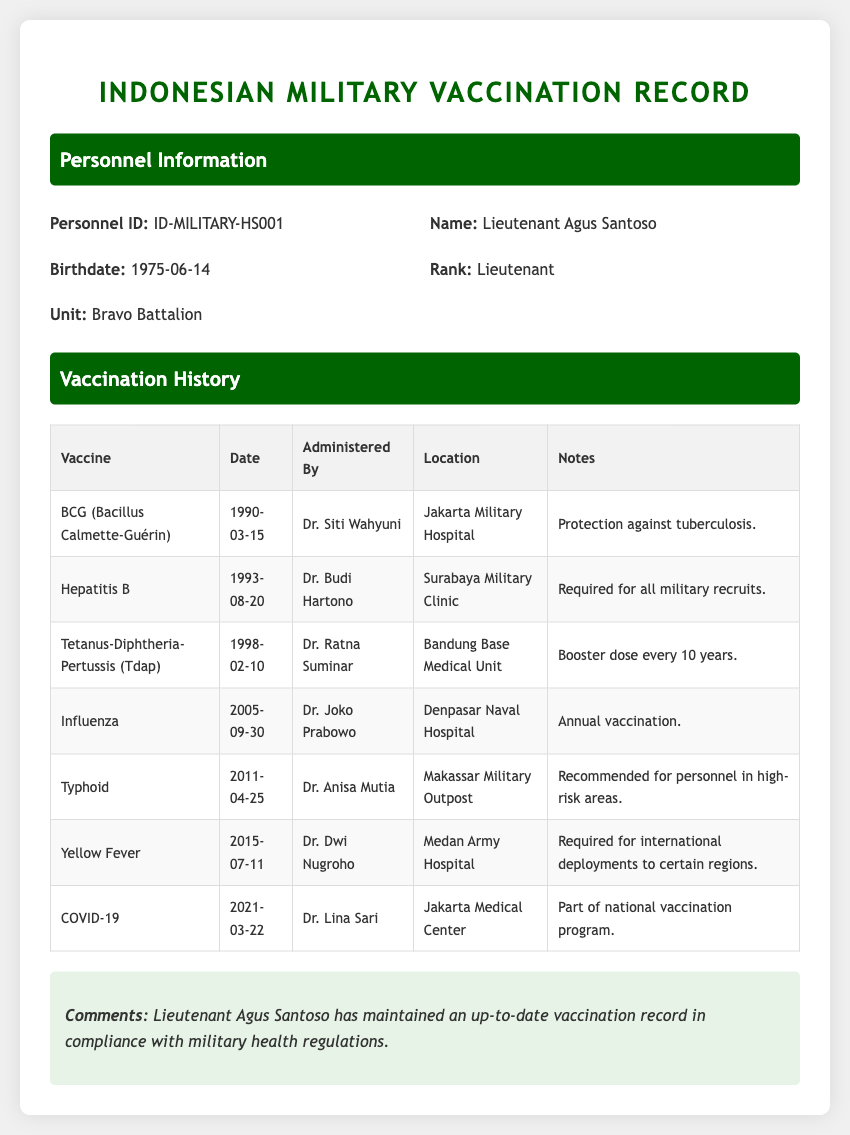What is the name of the personnel? The name of the personnel is stated in the personal information section of the document.
Answer: Lieutenant Agus Santoso What is the birthdate of the personnel? The birthdate of the personnel is provided in the personal information section.
Answer: 1975-06-14 How many vaccines has Lieutenant Agus Santoso received? The number of vaccines can be counted from the vaccination history table in the document.
Answer: 7 What vaccine was administered on 1990-03-15? The specific vaccine given on this date is listed in the vaccination history table.
Answer: BCG (Bacillus Calmette-Guérin) Who administered the COVID-19 vaccine? The name of the administering doctor is included in the vaccination history for the COVID-19 vaccine.
Answer: Dr. Lina Sari What is the purpose of the Yellow Fever vaccine? The purpose of each vaccine can be found in the notes column of the vaccination history table.
Answer: Required for international deployments to certain regions Where was the Tetanus-Diphtheria-Pertussis vaccine administered? The location of administration is specified in the vaccination history table.
Answer: Bandung Base Medical Unit What type of document is this? The nature of the document can be inferred from the title and content.
Answer: Medical record 